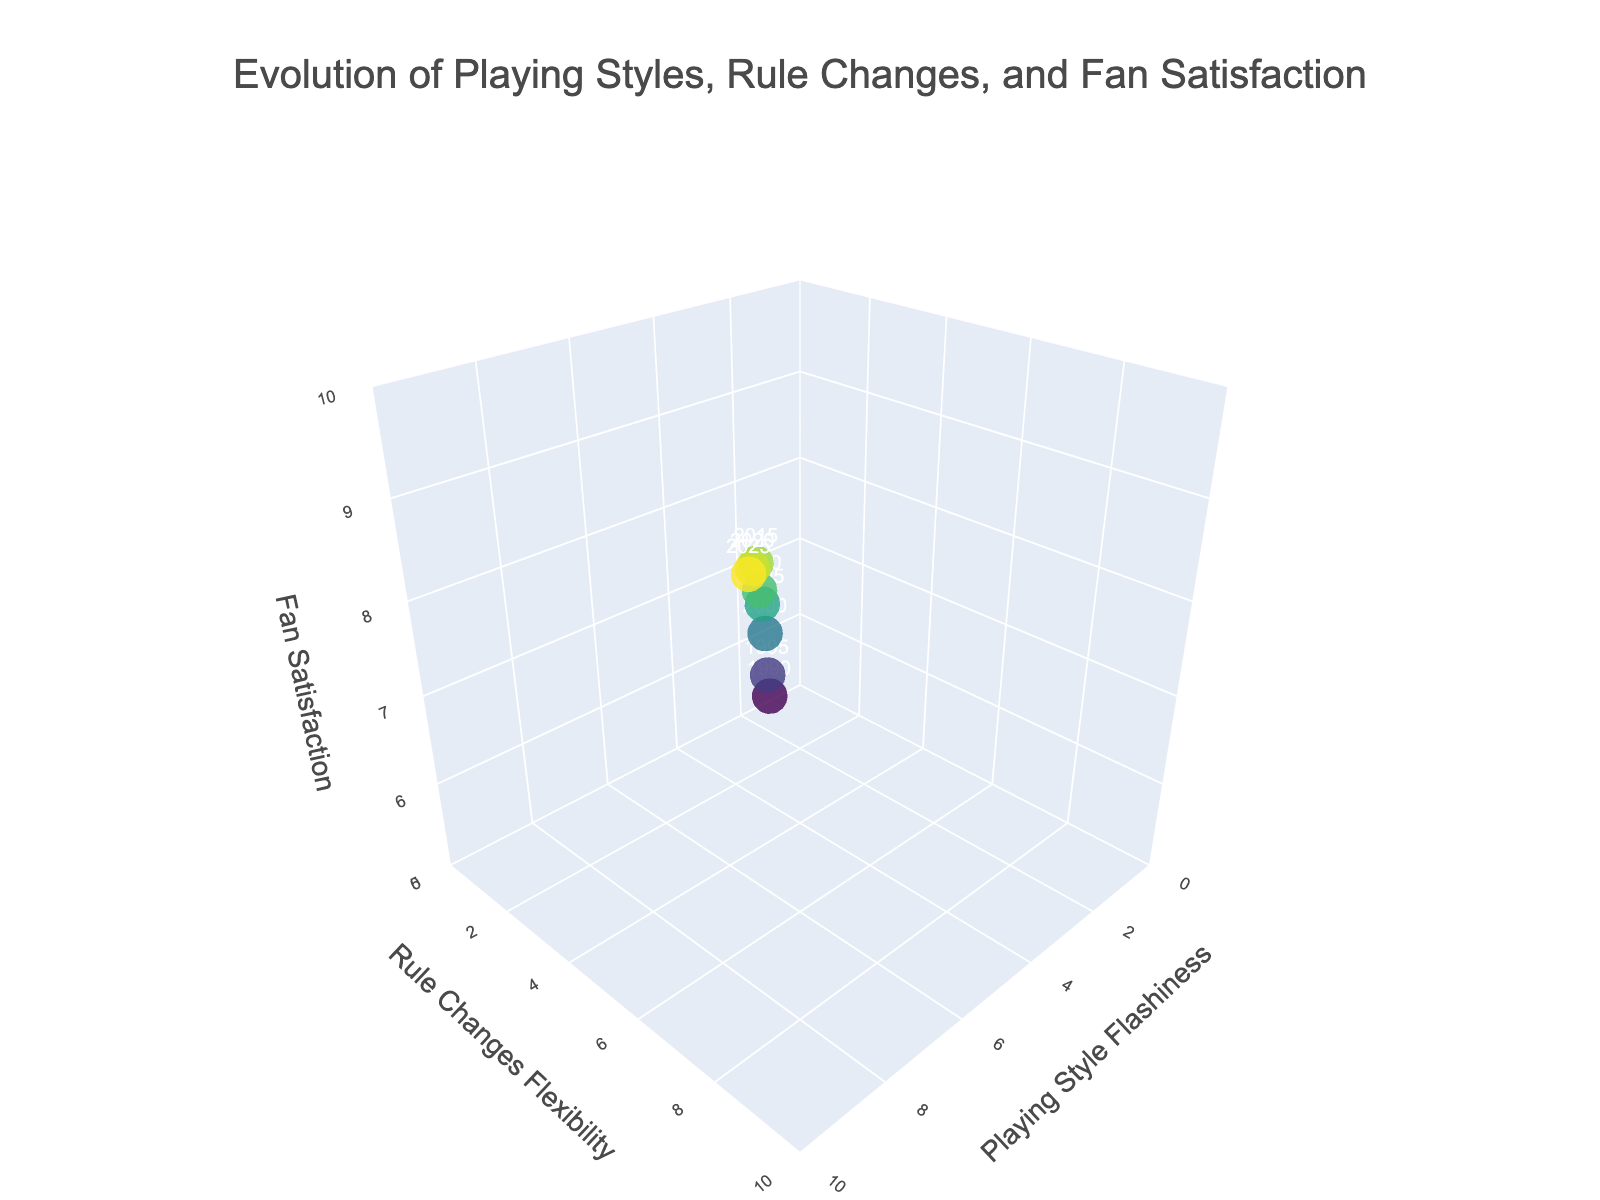What's the title of the figure? The title is located at the top of the figure in a larger font size and different coloration, making it easily identifiable.
Answer: Evolution of Playing Styles, Rule Changes, and Fan Satisfaction What are the labels of the axes in the figure? The axes are labeled in the plot with titles for each axis. The x-axis is "Playing Style Flashiness," the y-axis is "Rule Changes Flexibility," and the z-axis is "Fan Satisfaction."
Answer: Playing Style Flashiness, Rule Changes Flexibility, Fan Satisfaction How many data points are plotted in the figure? Each marker represents a data point, and a text label showing the year is displayed next to each marker. Counting these markers gives us the total number of data points.
Answer: 8 Which year corresponds to the highest Fan Satisfaction? The legend or the text markers next to the data points can be checked visually to identify the year with the highest value on the Fan Satisfaction (z) axis.
Answer: 2025 How did Fan Satisfaction change from 1990 to 2025? By comparing the position of the markers along the Fan Satisfaction (z) axis for the years 1990 and 2025, we can observe the difference.
Answer: Increased What's the difference in Rule Changes Flexibility between 2010 and 2020? Locate the markers for the years 2010 and 2020 and subtract the y-axis value of 2010 from that of 2020 to find the difference.
Answer: 2 What is the average Playing Style Flashiness from 1990 to 2025? Sum up the Playing Style Flashiness values for all years and divide by the number of data points (8). (2 + 3 + 4 + 5 + 6 + 7 + 8 + 9) / 8 = 5.5
Answer: 5.5 Is the Fan Satisfaction in 2000 less than in 2015? Compare the positions of the markers on the Fan Satisfaction (z) axis. The 2000 marker is at 7.1 and the 2015 marker is at 8.9. Therefore, 7.1 < 8.9.
Answer: Yes How does Rule Changes Flexibility correlate with Playing Style Flashiness? Look at the general trend of the plotted points along the x-axis and y-axis. Both axes show an increasing pattern, suggesting a positive correlation.
Answer: Positive correlation What would likely have the broadest range of values among the three plotted features? Evaluate the spread of the data visually across the axes ranges. Playing Style Flashiness and Rule Changes Flexibility both vary from 1 to 9, but Fan Satisfaction varies from 5.5 to 9.5.
Answer: Playing Style Flashiness 